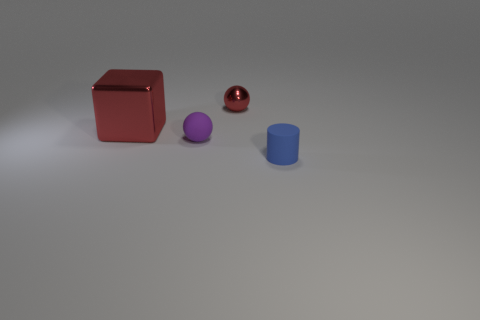What number of other things are the same color as the large metallic block?
Offer a terse response. 1. Is there any other thing that is the same shape as the purple object?
Keep it short and to the point. Yes. There is a tiny sphere that is on the right side of the rubber object that is to the left of the tiny red metal object; what is it made of?
Give a very brief answer. Metal. How big is the ball that is behind the purple rubber object?
Your answer should be very brief. Small. What is the color of the thing that is behind the small matte ball and to the left of the small red metal sphere?
Ensure brevity in your answer.  Red. There is a rubber thing that is behind the blue matte thing; is its size the same as the blue matte object?
Ensure brevity in your answer.  Yes. There is a small red metallic thing behind the purple matte object; are there any tiny purple matte things that are to the left of it?
Give a very brief answer. Yes. What is the tiny purple thing made of?
Ensure brevity in your answer.  Rubber. There is a tiny purple rubber object; are there any purple objects right of it?
Keep it short and to the point. No. There is a rubber object that is the same shape as the small red shiny thing; what size is it?
Offer a very short reply. Small. 